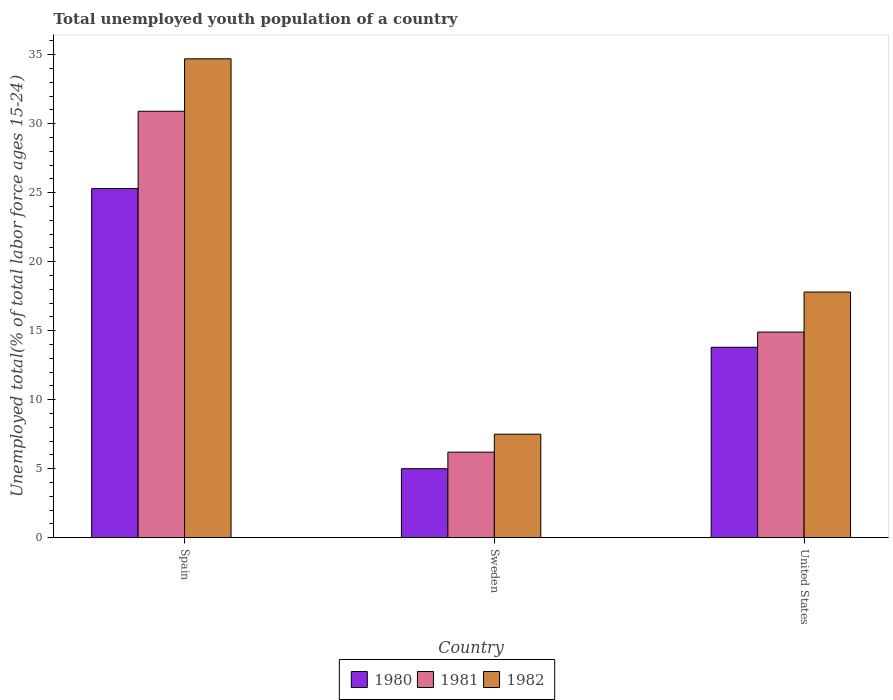Are the number of bars on each tick of the X-axis equal?
Keep it short and to the point. Yes. How many bars are there on the 3rd tick from the left?
Your answer should be very brief. 3. How many bars are there on the 3rd tick from the right?
Ensure brevity in your answer.  3. What is the percentage of total unemployed youth population of a country in 1982 in Spain?
Provide a short and direct response. 34.7. Across all countries, what is the maximum percentage of total unemployed youth population of a country in 1980?
Provide a succinct answer. 25.3. Across all countries, what is the minimum percentage of total unemployed youth population of a country in 1982?
Keep it short and to the point. 7.5. In which country was the percentage of total unemployed youth population of a country in 1982 minimum?
Your answer should be compact. Sweden. What is the total percentage of total unemployed youth population of a country in 1980 in the graph?
Your answer should be compact. 44.1. What is the difference between the percentage of total unemployed youth population of a country in 1982 in Spain and that in Sweden?
Provide a short and direct response. 27.2. What is the difference between the percentage of total unemployed youth population of a country in 1982 in United States and the percentage of total unemployed youth population of a country in 1980 in Sweden?
Your answer should be compact. 12.8. What is the average percentage of total unemployed youth population of a country in 1981 per country?
Ensure brevity in your answer.  17.33. What is the difference between the percentage of total unemployed youth population of a country of/in 1980 and percentage of total unemployed youth population of a country of/in 1981 in Spain?
Ensure brevity in your answer.  -5.6. What is the ratio of the percentage of total unemployed youth population of a country in 1980 in Spain to that in United States?
Ensure brevity in your answer.  1.83. Is the difference between the percentage of total unemployed youth population of a country in 1980 in Spain and United States greater than the difference between the percentage of total unemployed youth population of a country in 1981 in Spain and United States?
Offer a terse response. No. What is the difference between the highest and the second highest percentage of total unemployed youth population of a country in 1981?
Make the answer very short. -24.7. What is the difference between the highest and the lowest percentage of total unemployed youth population of a country in 1980?
Make the answer very short. 20.3. In how many countries, is the percentage of total unemployed youth population of a country in 1982 greater than the average percentage of total unemployed youth population of a country in 1982 taken over all countries?
Make the answer very short. 1. Is the sum of the percentage of total unemployed youth population of a country in 1980 in Spain and Sweden greater than the maximum percentage of total unemployed youth population of a country in 1981 across all countries?
Provide a short and direct response. No. How many bars are there?
Offer a very short reply. 9. How many countries are there in the graph?
Your answer should be very brief. 3. What is the difference between two consecutive major ticks on the Y-axis?
Provide a short and direct response. 5. Does the graph contain any zero values?
Make the answer very short. No. Where does the legend appear in the graph?
Give a very brief answer. Bottom center. How are the legend labels stacked?
Provide a succinct answer. Horizontal. What is the title of the graph?
Your answer should be very brief. Total unemployed youth population of a country. What is the label or title of the Y-axis?
Offer a terse response. Unemployed total(% of total labor force ages 15-24). What is the Unemployed total(% of total labor force ages 15-24) in 1980 in Spain?
Give a very brief answer. 25.3. What is the Unemployed total(% of total labor force ages 15-24) of 1981 in Spain?
Keep it short and to the point. 30.9. What is the Unemployed total(% of total labor force ages 15-24) of 1982 in Spain?
Offer a terse response. 34.7. What is the Unemployed total(% of total labor force ages 15-24) in 1981 in Sweden?
Make the answer very short. 6.2. What is the Unemployed total(% of total labor force ages 15-24) of 1982 in Sweden?
Provide a succinct answer. 7.5. What is the Unemployed total(% of total labor force ages 15-24) of 1980 in United States?
Your answer should be compact. 13.8. What is the Unemployed total(% of total labor force ages 15-24) of 1981 in United States?
Provide a short and direct response. 14.9. What is the Unemployed total(% of total labor force ages 15-24) in 1982 in United States?
Your response must be concise. 17.8. Across all countries, what is the maximum Unemployed total(% of total labor force ages 15-24) of 1980?
Your answer should be very brief. 25.3. Across all countries, what is the maximum Unemployed total(% of total labor force ages 15-24) in 1981?
Make the answer very short. 30.9. Across all countries, what is the maximum Unemployed total(% of total labor force ages 15-24) in 1982?
Offer a terse response. 34.7. Across all countries, what is the minimum Unemployed total(% of total labor force ages 15-24) in 1980?
Your answer should be compact. 5. Across all countries, what is the minimum Unemployed total(% of total labor force ages 15-24) of 1981?
Your answer should be compact. 6.2. What is the total Unemployed total(% of total labor force ages 15-24) in 1980 in the graph?
Your answer should be very brief. 44.1. What is the total Unemployed total(% of total labor force ages 15-24) in 1982 in the graph?
Your response must be concise. 60. What is the difference between the Unemployed total(% of total labor force ages 15-24) of 1980 in Spain and that in Sweden?
Offer a very short reply. 20.3. What is the difference between the Unemployed total(% of total labor force ages 15-24) of 1981 in Spain and that in Sweden?
Make the answer very short. 24.7. What is the difference between the Unemployed total(% of total labor force ages 15-24) in 1982 in Spain and that in Sweden?
Provide a succinct answer. 27.2. What is the difference between the Unemployed total(% of total labor force ages 15-24) in 1981 in Spain and that in United States?
Give a very brief answer. 16. What is the difference between the Unemployed total(% of total labor force ages 15-24) of 1981 in Spain and the Unemployed total(% of total labor force ages 15-24) of 1982 in Sweden?
Provide a succinct answer. 23.4. What is the difference between the Unemployed total(% of total labor force ages 15-24) of 1980 in Spain and the Unemployed total(% of total labor force ages 15-24) of 1982 in United States?
Your answer should be compact. 7.5. What is the difference between the Unemployed total(% of total labor force ages 15-24) in 1980 in Sweden and the Unemployed total(% of total labor force ages 15-24) in 1981 in United States?
Offer a very short reply. -9.9. What is the difference between the Unemployed total(% of total labor force ages 15-24) in 1980 in Sweden and the Unemployed total(% of total labor force ages 15-24) in 1982 in United States?
Make the answer very short. -12.8. What is the difference between the Unemployed total(% of total labor force ages 15-24) of 1981 in Sweden and the Unemployed total(% of total labor force ages 15-24) of 1982 in United States?
Ensure brevity in your answer.  -11.6. What is the average Unemployed total(% of total labor force ages 15-24) in 1981 per country?
Your answer should be very brief. 17.33. What is the difference between the Unemployed total(% of total labor force ages 15-24) of 1980 and Unemployed total(% of total labor force ages 15-24) of 1981 in Spain?
Make the answer very short. -5.6. What is the difference between the Unemployed total(% of total labor force ages 15-24) in 1981 and Unemployed total(% of total labor force ages 15-24) in 1982 in Spain?
Your response must be concise. -3.8. What is the difference between the Unemployed total(% of total labor force ages 15-24) in 1980 and Unemployed total(% of total labor force ages 15-24) in 1981 in Sweden?
Provide a short and direct response. -1.2. What is the difference between the Unemployed total(% of total labor force ages 15-24) in 1980 and Unemployed total(% of total labor force ages 15-24) in 1982 in Sweden?
Offer a terse response. -2.5. What is the difference between the Unemployed total(% of total labor force ages 15-24) in 1981 and Unemployed total(% of total labor force ages 15-24) in 1982 in Sweden?
Your answer should be compact. -1.3. What is the difference between the Unemployed total(% of total labor force ages 15-24) of 1980 and Unemployed total(% of total labor force ages 15-24) of 1981 in United States?
Provide a short and direct response. -1.1. What is the difference between the Unemployed total(% of total labor force ages 15-24) of 1981 and Unemployed total(% of total labor force ages 15-24) of 1982 in United States?
Provide a short and direct response. -2.9. What is the ratio of the Unemployed total(% of total labor force ages 15-24) of 1980 in Spain to that in Sweden?
Make the answer very short. 5.06. What is the ratio of the Unemployed total(% of total labor force ages 15-24) of 1981 in Spain to that in Sweden?
Provide a short and direct response. 4.98. What is the ratio of the Unemployed total(% of total labor force ages 15-24) in 1982 in Spain to that in Sweden?
Give a very brief answer. 4.63. What is the ratio of the Unemployed total(% of total labor force ages 15-24) of 1980 in Spain to that in United States?
Give a very brief answer. 1.83. What is the ratio of the Unemployed total(% of total labor force ages 15-24) of 1981 in Spain to that in United States?
Make the answer very short. 2.07. What is the ratio of the Unemployed total(% of total labor force ages 15-24) in 1982 in Spain to that in United States?
Your answer should be compact. 1.95. What is the ratio of the Unemployed total(% of total labor force ages 15-24) of 1980 in Sweden to that in United States?
Keep it short and to the point. 0.36. What is the ratio of the Unemployed total(% of total labor force ages 15-24) of 1981 in Sweden to that in United States?
Your answer should be compact. 0.42. What is the ratio of the Unemployed total(% of total labor force ages 15-24) of 1982 in Sweden to that in United States?
Your answer should be compact. 0.42. What is the difference between the highest and the second highest Unemployed total(% of total labor force ages 15-24) in 1982?
Offer a terse response. 16.9. What is the difference between the highest and the lowest Unemployed total(% of total labor force ages 15-24) of 1980?
Keep it short and to the point. 20.3. What is the difference between the highest and the lowest Unemployed total(% of total labor force ages 15-24) of 1981?
Your response must be concise. 24.7. What is the difference between the highest and the lowest Unemployed total(% of total labor force ages 15-24) of 1982?
Provide a short and direct response. 27.2. 